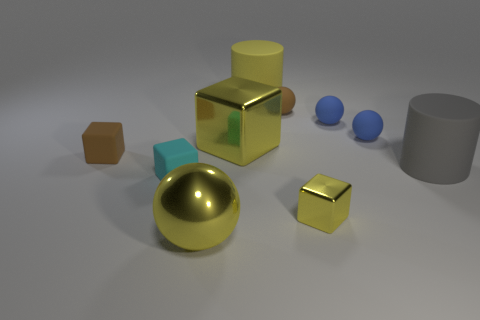Subtract all gray balls. Subtract all gray cubes. How many balls are left? 4 Subtract all balls. How many objects are left? 6 Add 4 large gray matte things. How many large gray matte things exist? 5 Subtract 0 purple balls. How many objects are left? 10 Subtract all big yellow blocks. Subtract all tiny brown matte balls. How many objects are left? 8 Add 8 big gray objects. How many big gray objects are left? 9 